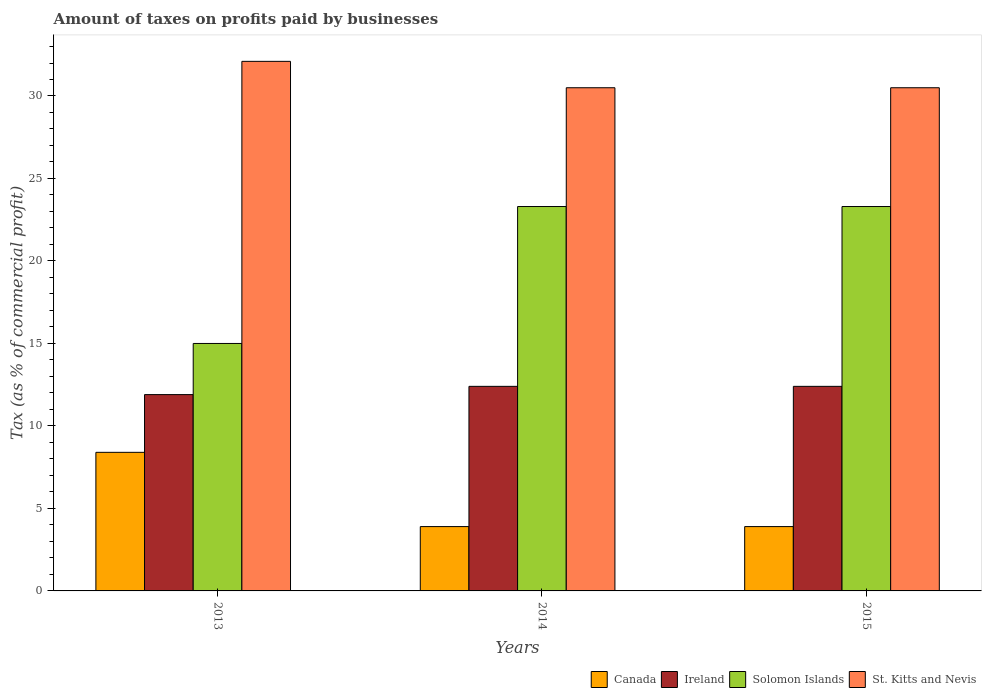How many different coloured bars are there?
Keep it short and to the point. 4. Are the number of bars on each tick of the X-axis equal?
Offer a very short reply. Yes. How many bars are there on the 1st tick from the left?
Ensure brevity in your answer.  4. What is the label of the 1st group of bars from the left?
Provide a short and direct response. 2013. In how many cases, is the number of bars for a given year not equal to the number of legend labels?
Offer a terse response. 0. In which year was the percentage of taxes paid by businesses in St. Kitts and Nevis minimum?
Provide a succinct answer. 2014. What is the total percentage of taxes paid by businesses in St. Kitts and Nevis in the graph?
Give a very brief answer. 93.1. What is the difference between the percentage of taxes paid by businesses in Canada in 2013 and that in 2014?
Make the answer very short. 4.5. What is the difference between the percentage of taxes paid by businesses in St. Kitts and Nevis in 2015 and the percentage of taxes paid by businesses in Canada in 2014?
Offer a terse response. 26.6. What is the average percentage of taxes paid by businesses in St. Kitts and Nevis per year?
Offer a very short reply. 31.03. In the year 2014, what is the difference between the percentage of taxes paid by businesses in Canada and percentage of taxes paid by businesses in Ireland?
Your answer should be compact. -8.5. In how many years, is the percentage of taxes paid by businesses in Ireland greater than 16 %?
Make the answer very short. 0. What is the ratio of the percentage of taxes paid by businesses in Ireland in 2013 to that in 2014?
Offer a terse response. 0.96. Is the difference between the percentage of taxes paid by businesses in Canada in 2014 and 2015 greater than the difference between the percentage of taxes paid by businesses in Ireland in 2014 and 2015?
Provide a succinct answer. No. What is the difference between the highest and the second highest percentage of taxes paid by businesses in St. Kitts and Nevis?
Make the answer very short. 1.6. What is the difference between the highest and the lowest percentage of taxes paid by businesses in Solomon Islands?
Offer a terse response. 8.3. What does the 1st bar from the left in 2014 represents?
Your answer should be very brief. Canada. Is it the case that in every year, the sum of the percentage of taxes paid by businesses in Ireland and percentage of taxes paid by businesses in Solomon Islands is greater than the percentage of taxes paid by businesses in Canada?
Give a very brief answer. Yes. How many bars are there?
Your response must be concise. 12. Are all the bars in the graph horizontal?
Provide a succinct answer. No. Are the values on the major ticks of Y-axis written in scientific E-notation?
Provide a succinct answer. No. Does the graph contain grids?
Give a very brief answer. No. How many legend labels are there?
Your answer should be very brief. 4. How are the legend labels stacked?
Provide a short and direct response. Horizontal. What is the title of the graph?
Make the answer very short. Amount of taxes on profits paid by businesses. Does "Guatemala" appear as one of the legend labels in the graph?
Offer a terse response. No. What is the label or title of the Y-axis?
Make the answer very short. Tax (as % of commercial profit). What is the Tax (as % of commercial profit) of Canada in 2013?
Make the answer very short. 8.4. What is the Tax (as % of commercial profit) in Ireland in 2013?
Your answer should be compact. 11.9. What is the Tax (as % of commercial profit) of St. Kitts and Nevis in 2013?
Your answer should be compact. 32.1. What is the Tax (as % of commercial profit) in Canada in 2014?
Your answer should be very brief. 3.9. What is the Tax (as % of commercial profit) of Ireland in 2014?
Offer a terse response. 12.4. What is the Tax (as % of commercial profit) in Solomon Islands in 2014?
Your response must be concise. 23.3. What is the Tax (as % of commercial profit) in St. Kitts and Nevis in 2014?
Offer a very short reply. 30.5. What is the Tax (as % of commercial profit) of Ireland in 2015?
Provide a succinct answer. 12.4. What is the Tax (as % of commercial profit) of Solomon Islands in 2015?
Keep it short and to the point. 23.3. What is the Tax (as % of commercial profit) in St. Kitts and Nevis in 2015?
Your response must be concise. 30.5. Across all years, what is the maximum Tax (as % of commercial profit) of Ireland?
Offer a very short reply. 12.4. Across all years, what is the maximum Tax (as % of commercial profit) in Solomon Islands?
Make the answer very short. 23.3. Across all years, what is the maximum Tax (as % of commercial profit) in St. Kitts and Nevis?
Provide a succinct answer. 32.1. Across all years, what is the minimum Tax (as % of commercial profit) in Solomon Islands?
Your response must be concise. 15. Across all years, what is the minimum Tax (as % of commercial profit) in St. Kitts and Nevis?
Make the answer very short. 30.5. What is the total Tax (as % of commercial profit) of Ireland in the graph?
Give a very brief answer. 36.7. What is the total Tax (as % of commercial profit) of Solomon Islands in the graph?
Offer a very short reply. 61.6. What is the total Tax (as % of commercial profit) of St. Kitts and Nevis in the graph?
Offer a very short reply. 93.1. What is the difference between the Tax (as % of commercial profit) in Canada in 2013 and that in 2014?
Offer a terse response. 4.5. What is the difference between the Tax (as % of commercial profit) of Ireland in 2013 and that in 2014?
Your response must be concise. -0.5. What is the difference between the Tax (as % of commercial profit) in Solomon Islands in 2013 and that in 2014?
Make the answer very short. -8.3. What is the difference between the Tax (as % of commercial profit) in St. Kitts and Nevis in 2013 and that in 2014?
Make the answer very short. 1.6. What is the difference between the Tax (as % of commercial profit) in Canada in 2013 and that in 2015?
Offer a very short reply. 4.5. What is the difference between the Tax (as % of commercial profit) of Solomon Islands in 2013 and that in 2015?
Your answer should be very brief. -8.3. What is the difference between the Tax (as % of commercial profit) of St. Kitts and Nevis in 2013 and that in 2015?
Offer a very short reply. 1.6. What is the difference between the Tax (as % of commercial profit) in Canada in 2014 and that in 2015?
Offer a terse response. 0. What is the difference between the Tax (as % of commercial profit) of Solomon Islands in 2014 and that in 2015?
Offer a terse response. 0. What is the difference between the Tax (as % of commercial profit) of St. Kitts and Nevis in 2014 and that in 2015?
Offer a terse response. 0. What is the difference between the Tax (as % of commercial profit) of Canada in 2013 and the Tax (as % of commercial profit) of Solomon Islands in 2014?
Ensure brevity in your answer.  -14.9. What is the difference between the Tax (as % of commercial profit) of Canada in 2013 and the Tax (as % of commercial profit) of St. Kitts and Nevis in 2014?
Offer a very short reply. -22.1. What is the difference between the Tax (as % of commercial profit) in Ireland in 2013 and the Tax (as % of commercial profit) in St. Kitts and Nevis in 2014?
Offer a very short reply. -18.6. What is the difference between the Tax (as % of commercial profit) in Solomon Islands in 2013 and the Tax (as % of commercial profit) in St. Kitts and Nevis in 2014?
Make the answer very short. -15.5. What is the difference between the Tax (as % of commercial profit) in Canada in 2013 and the Tax (as % of commercial profit) in Solomon Islands in 2015?
Your answer should be very brief. -14.9. What is the difference between the Tax (as % of commercial profit) in Canada in 2013 and the Tax (as % of commercial profit) in St. Kitts and Nevis in 2015?
Make the answer very short. -22.1. What is the difference between the Tax (as % of commercial profit) in Ireland in 2013 and the Tax (as % of commercial profit) in St. Kitts and Nevis in 2015?
Your answer should be very brief. -18.6. What is the difference between the Tax (as % of commercial profit) of Solomon Islands in 2013 and the Tax (as % of commercial profit) of St. Kitts and Nevis in 2015?
Offer a very short reply. -15.5. What is the difference between the Tax (as % of commercial profit) in Canada in 2014 and the Tax (as % of commercial profit) in Ireland in 2015?
Your answer should be very brief. -8.5. What is the difference between the Tax (as % of commercial profit) of Canada in 2014 and the Tax (as % of commercial profit) of Solomon Islands in 2015?
Make the answer very short. -19.4. What is the difference between the Tax (as % of commercial profit) of Canada in 2014 and the Tax (as % of commercial profit) of St. Kitts and Nevis in 2015?
Your answer should be very brief. -26.6. What is the difference between the Tax (as % of commercial profit) of Ireland in 2014 and the Tax (as % of commercial profit) of Solomon Islands in 2015?
Offer a very short reply. -10.9. What is the difference between the Tax (as % of commercial profit) in Ireland in 2014 and the Tax (as % of commercial profit) in St. Kitts and Nevis in 2015?
Your answer should be very brief. -18.1. What is the difference between the Tax (as % of commercial profit) of Solomon Islands in 2014 and the Tax (as % of commercial profit) of St. Kitts and Nevis in 2015?
Keep it short and to the point. -7.2. What is the average Tax (as % of commercial profit) of Ireland per year?
Your response must be concise. 12.23. What is the average Tax (as % of commercial profit) in Solomon Islands per year?
Offer a terse response. 20.53. What is the average Tax (as % of commercial profit) of St. Kitts and Nevis per year?
Your answer should be compact. 31.03. In the year 2013, what is the difference between the Tax (as % of commercial profit) of Canada and Tax (as % of commercial profit) of Ireland?
Provide a succinct answer. -3.5. In the year 2013, what is the difference between the Tax (as % of commercial profit) of Canada and Tax (as % of commercial profit) of St. Kitts and Nevis?
Your answer should be very brief. -23.7. In the year 2013, what is the difference between the Tax (as % of commercial profit) of Ireland and Tax (as % of commercial profit) of St. Kitts and Nevis?
Offer a terse response. -20.2. In the year 2013, what is the difference between the Tax (as % of commercial profit) in Solomon Islands and Tax (as % of commercial profit) in St. Kitts and Nevis?
Offer a terse response. -17.1. In the year 2014, what is the difference between the Tax (as % of commercial profit) in Canada and Tax (as % of commercial profit) in Solomon Islands?
Your response must be concise. -19.4. In the year 2014, what is the difference between the Tax (as % of commercial profit) in Canada and Tax (as % of commercial profit) in St. Kitts and Nevis?
Your answer should be compact. -26.6. In the year 2014, what is the difference between the Tax (as % of commercial profit) of Ireland and Tax (as % of commercial profit) of St. Kitts and Nevis?
Offer a terse response. -18.1. In the year 2015, what is the difference between the Tax (as % of commercial profit) in Canada and Tax (as % of commercial profit) in Ireland?
Make the answer very short. -8.5. In the year 2015, what is the difference between the Tax (as % of commercial profit) in Canada and Tax (as % of commercial profit) in Solomon Islands?
Your response must be concise. -19.4. In the year 2015, what is the difference between the Tax (as % of commercial profit) of Canada and Tax (as % of commercial profit) of St. Kitts and Nevis?
Offer a terse response. -26.6. In the year 2015, what is the difference between the Tax (as % of commercial profit) in Ireland and Tax (as % of commercial profit) in St. Kitts and Nevis?
Provide a succinct answer. -18.1. In the year 2015, what is the difference between the Tax (as % of commercial profit) in Solomon Islands and Tax (as % of commercial profit) in St. Kitts and Nevis?
Make the answer very short. -7.2. What is the ratio of the Tax (as % of commercial profit) in Canada in 2013 to that in 2014?
Your response must be concise. 2.15. What is the ratio of the Tax (as % of commercial profit) in Ireland in 2013 to that in 2014?
Provide a succinct answer. 0.96. What is the ratio of the Tax (as % of commercial profit) in Solomon Islands in 2013 to that in 2014?
Provide a succinct answer. 0.64. What is the ratio of the Tax (as % of commercial profit) of St. Kitts and Nevis in 2013 to that in 2014?
Your answer should be very brief. 1.05. What is the ratio of the Tax (as % of commercial profit) in Canada in 2013 to that in 2015?
Your answer should be compact. 2.15. What is the ratio of the Tax (as % of commercial profit) of Ireland in 2013 to that in 2015?
Ensure brevity in your answer.  0.96. What is the ratio of the Tax (as % of commercial profit) of Solomon Islands in 2013 to that in 2015?
Your answer should be very brief. 0.64. What is the ratio of the Tax (as % of commercial profit) in St. Kitts and Nevis in 2013 to that in 2015?
Make the answer very short. 1.05. What is the ratio of the Tax (as % of commercial profit) of Canada in 2014 to that in 2015?
Keep it short and to the point. 1. What is the ratio of the Tax (as % of commercial profit) of Ireland in 2014 to that in 2015?
Make the answer very short. 1. What is the ratio of the Tax (as % of commercial profit) in Solomon Islands in 2014 to that in 2015?
Provide a short and direct response. 1. What is the difference between the highest and the second highest Tax (as % of commercial profit) of St. Kitts and Nevis?
Ensure brevity in your answer.  1.6. What is the difference between the highest and the lowest Tax (as % of commercial profit) of Canada?
Give a very brief answer. 4.5. What is the difference between the highest and the lowest Tax (as % of commercial profit) in Solomon Islands?
Your response must be concise. 8.3. 